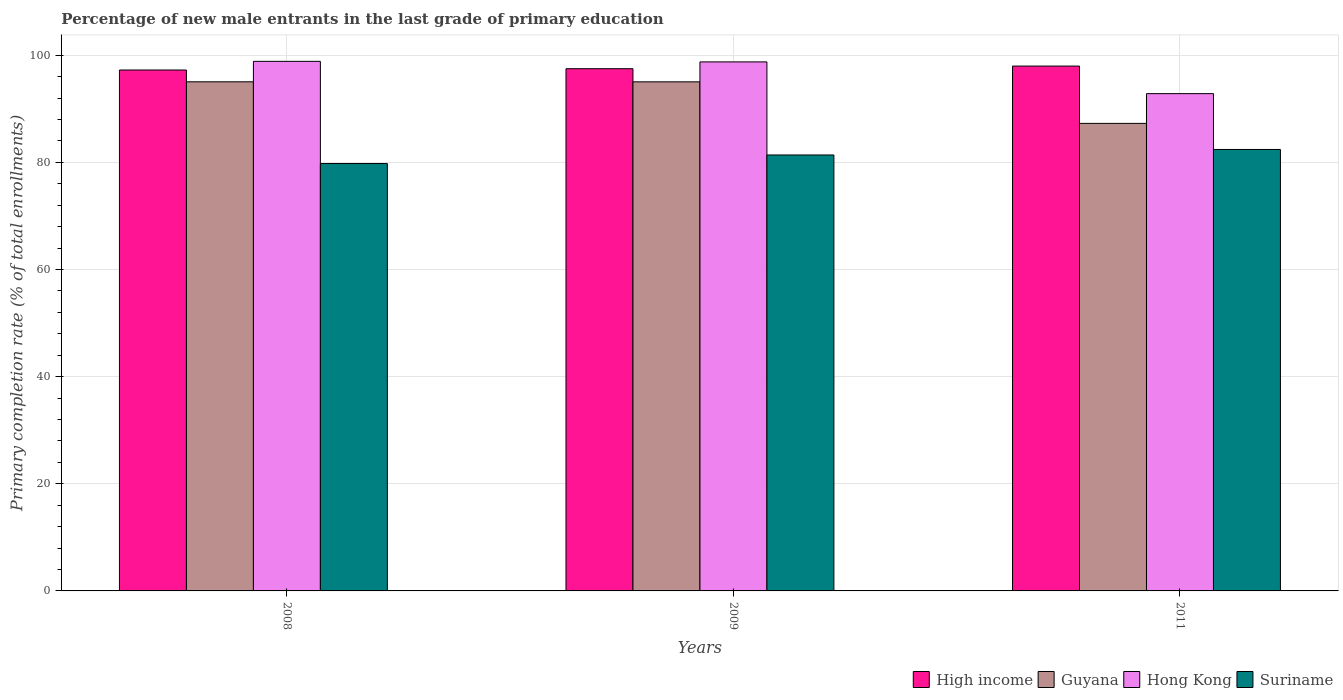Are the number of bars on each tick of the X-axis equal?
Give a very brief answer. Yes. How many bars are there on the 3rd tick from the right?
Keep it short and to the point. 4. What is the label of the 1st group of bars from the left?
Ensure brevity in your answer.  2008. In how many cases, is the number of bars for a given year not equal to the number of legend labels?
Your answer should be compact. 0. What is the percentage of new male entrants in High income in 2009?
Keep it short and to the point. 97.49. Across all years, what is the maximum percentage of new male entrants in Suriname?
Your answer should be compact. 82.41. Across all years, what is the minimum percentage of new male entrants in Hong Kong?
Your response must be concise. 92.83. In which year was the percentage of new male entrants in High income maximum?
Your answer should be very brief. 2011. In which year was the percentage of new male entrants in Hong Kong minimum?
Your response must be concise. 2011. What is the total percentage of new male entrants in Suriname in the graph?
Your answer should be compact. 243.57. What is the difference between the percentage of new male entrants in Guyana in 2009 and that in 2011?
Your answer should be compact. 7.75. What is the difference between the percentage of new male entrants in Guyana in 2008 and the percentage of new male entrants in Hong Kong in 2009?
Give a very brief answer. -3.72. What is the average percentage of new male entrants in High income per year?
Offer a terse response. 97.57. In the year 2011, what is the difference between the percentage of new male entrants in Guyana and percentage of new male entrants in Hong Kong?
Provide a short and direct response. -5.55. What is the ratio of the percentage of new male entrants in Guyana in 2008 to that in 2009?
Your answer should be very brief. 1. Is the difference between the percentage of new male entrants in Guyana in 2008 and 2009 greater than the difference between the percentage of new male entrants in Hong Kong in 2008 and 2009?
Provide a short and direct response. No. What is the difference between the highest and the second highest percentage of new male entrants in Guyana?
Offer a very short reply. 0.01. What is the difference between the highest and the lowest percentage of new male entrants in Guyana?
Offer a terse response. 7.76. In how many years, is the percentage of new male entrants in Guyana greater than the average percentage of new male entrants in Guyana taken over all years?
Keep it short and to the point. 2. Is the sum of the percentage of new male entrants in Guyana in 2009 and 2011 greater than the maximum percentage of new male entrants in High income across all years?
Your answer should be very brief. Yes. Is it the case that in every year, the sum of the percentage of new male entrants in High income and percentage of new male entrants in Guyana is greater than the sum of percentage of new male entrants in Suriname and percentage of new male entrants in Hong Kong?
Make the answer very short. No. What does the 3rd bar from the left in 2011 represents?
Offer a very short reply. Hong Kong. What does the 4th bar from the right in 2008 represents?
Provide a succinct answer. High income. Is it the case that in every year, the sum of the percentage of new male entrants in Hong Kong and percentage of new male entrants in High income is greater than the percentage of new male entrants in Guyana?
Your answer should be very brief. Yes. How many bars are there?
Keep it short and to the point. 12. What is the difference between two consecutive major ticks on the Y-axis?
Ensure brevity in your answer.  20. Does the graph contain grids?
Provide a short and direct response. Yes. How many legend labels are there?
Your answer should be compact. 4. How are the legend labels stacked?
Give a very brief answer. Horizontal. What is the title of the graph?
Offer a terse response. Percentage of new male entrants in the last grade of primary education. Does "Nicaragua" appear as one of the legend labels in the graph?
Offer a very short reply. No. What is the label or title of the Y-axis?
Offer a very short reply. Primary completion rate (% of total enrollments). What is the Primary completion rate (% of total enrollments) in High income in 2008?
Ensure brevity in your answer.  97.24. What is the Primary completion rate (% of total enrollments) in Guyana in 2008?
Make the answer very short. 95.04. What is the Primary completion rate (% of total enrollments) in Hong Kong in 2008?
Ensure brevity in your answer.  98.86. What is the Primary completion rate (% of total enrollments) of Suriname in 2008?
Ensure brevity in your answer.  79.78. What is the Primary completion rate (% of total enrollments) in High income in 2009?
Your answer should be compact. 97.49. What is the Primary completion rate (% of total enrollments) of Guyana in 2009?
Ensure brevity in your answer.  95.03. What is the Primary completion rate (% of total enrollments) in Hong Kong in 2009?
Keep it short and to the point. 98.76. What is the Primary completion rate (% of total enrollments) of Suriname in 2009?
Your response must be concise. 81.38. What is the Primary completion rate (% of total enrollments) of High income in 2011?
Offer a very short reply. 97.98. What is the Primary completion rate (% of total enrollments) in Guyana in 2011?
Your answer should be compact. 87.28. What is the Primary completion rate (% of total enrollments) in Hong Kong in 2011?
Make the answer very short. 92.83. What is the Primary completion rate (% of total enrollments) in Suriname in 2011?
Your answer should be compact. 82.41. Across all years, what is the maximum Primary completion rate (% of total enrollments) in High income?
Give a very brief answer. 97.98. Across all years, what is the maximum Primary completion rate (% of total enrollments) in Guyana?
Your response must be concise. 95.04. Across all years, what is the maximum Primary completion rate (% of total enrollments) in Hong Kong?
Make the answer very short. 98.86. Across all years, what is the maximum Primary completion rate (% of total enrollments) in Suriname?
Ensure brevity in your answer.  82.41. Across all years, what is the minimum Primary completion rate (% of total enrollments) of High income?
Provide a short and direct response. 97.24. Across all years, what is the minimum Primary completion rate (% of total enrollments) of Guyana?
Your answer should be very brief. 87.28. Across all years, what is the minimum Primary completion rate (% of total enrollments) of Hong Kong?
Your answer should be very brief. 92.83. Across all years, what is the minimum Primary completion rate (% of total enrollments) in Suriname?
Offer a very short reply. 79.78. What is the total Primary completion rate (% of total enrollments) in High income in the graph?
Keep it short and to the point. 292.7. What is the total Primary completion rate (% of total enrollments) of Guyana in the graph?
Provide a short and direct response. 277.35. What is the total Primary completion rate (% of total enrollments) of Hong Kong in the graph?
Your answer should be very brief. 290.44. What is the total Primary completion rate (% of total enrollments) of Suriname in the graph?
Offer a terse response. 243.57. What is the difference between the Primary completion rate (% of total enrollments) of High income in 2008 and that in 2009?
Give a very brief answer. -0.24. What is the difference between the Primary completion rate (% of total enrollments) of Guyana in 2008 and that in 2009?
Ensure brevity in your answer.  0.01. What is the difference between the Primary completion rate (% of total enrollments) in Hong Kong in 2008 and that in 2009?
Your answer should be very brief. 0.1. What is the difference between the Primary completion rate (% of total enrollments) in Suriname in 2008 and that in 2009?
Your response must be concise. -1.6. What is the difference between the Primary completion rate (% of total enrollments) of High income in 2008 and that in 2011?
Give a very brief answer. -0.73. What is the difference between the Primary completion rate (% of total enrollments) of Guyana in 2008 and that in 2011?
Offer a very short reply. 7.76. What is the difference between the Primary completion rate (% of total enrollments) in Hong Kong in 2008 and that in 2011?
Your response must be concise. 6.02. What is the difference between the Primary completion rate (% of total enrollments) in Suriname in 2008 and that in 2011?
Make the answer very short. -2.62. What is the difference between the Primary completion rate (% of total enrollments) of High income in 2009 and that in 2011?
Your response must be concise. -0.49. What is the difference between the Primary completion rate (% of total enrollments) in Guyana in 2009 and that in 2011?
Offer a very short reply. 7.75. What is the difference between the Primary completion rate (% of total enrollments) of Hong Kong in 2009 and that in 2011?
Make the answer very short. 5.92. What is the difference between the Primary completion rate (% of total enrollments) in Suriname in 2009 and that in 2011?
Make the answer very short. -1.03. What is the difference between the Primary completion rate (% of total enrollments) of High income in 2008 and the Primary completion rate (% of total enrollments) of Guyana in 2009?
Give a very brief answer. 2.21. What is the difference between the Primary completion rate (% of total enrollments) in High income in 2008 and the Primary completion rate (% of total enrollments) in Hong Kong in 2009?
Offer a very short reply. -1.51. What is the difference between the Primary completion rate (% of total enrollments) of High income in 2008 and the Primary completion rate (% of total enrollments) of Suriname in 2009?
Provide a succinct answer. 15.86. What is the difference between the Primary completion rate (% of total enrollments) of Guyana in 2008 and the Primary completion rate (% of total enrollments) of Hong Kong in 2009?
Your response must be concise. -3.72. What is the difference between the Primary completion rate (% of total enrollments) in Guyana in 2008 and the Primary completion rate (% of total enrollments) in Suriname in 2009?
Keep it short and to the point. 13.66. What is the difference between the Primary completion rate (% of total enrollments) in Hong Kong in 2008 and the Primary completion rate (% of total enrollments) in Suriname in 2009?
Provide a succinct answer. 17.48. What is the difference between the Primary completion rate (% of total enrollments) in High income in 2008 and the Primary completion rate (% of total enrollments) in Guyana in 2011?
Ensure brevity in your answer.  9.96. What is the difference between the Primary completion rate (% of total enrollments) in High income in 2008 and the Primary completion rate (% of total enrollments) in Hong Kong in 2011?
Your answer should be compact. 4.41. What is the difference between the Primary completion rate (% of total enrollments) of High income in 2008 and the Primary completion rate (% of total enrollments) of Suriname in 2011?
Ensure brevity in your answer.  14.83. What is the difference between the Primary completion rate (% of total enrollments) in Guyana in 2008 and the Primary completion rate (% of total enrollments) in Hong Kong in 2011?
Ensure brevity in your answer.  2.21. What is the difference between the Primary completion rate (% of total enrollments) in Guyana in 2008 and the Primary completion rate (% of total enrollments) in Suriname in 2011?
Make the answer very short. 12.63. What is the difference between the Primary completion rate (% of total enrollments) of Hong Kong in 2008 and the Primary completion rate (% of total enrollments) of Suriname in 2011?
Make the answer very short. 16.45. What is the difference between the Primary completion rate (% of total enrollments) of High income in 2009 and the Primary completion rate (% of total enrollments) of Guyana in 2011?
Your answer should be compact. 10.21. What is the difference between the Primary completion rate (% of total enrollments) in High income in 2009 and the Primary completion rate (% of total enrollments) in Hong Kong in 2011?
Your response must be concise. 4.65. What is the difference between the Primary completion rate (% of total enrollments) in High income in 2009 and the Primary completion rate (% of total enrollments) in Suriname in 2011?
Keep it short and to the point. 15.08. What is the difference between the Primary completion rate (% of total enrollments) of Guyana in 2009 and the Primary completion rate (% of total enrollments) of Hong Kong in 2011?
Provide a short and direct response. 2.2. What is the difference between the Primary completion rate (% of total enrollments) of Guyana in 2009 and the Primary completion rate (% of total enrollments) of Suriname in 2011?
Offer a very short reply. 12.62. What is the difference between the Primary completion rate (% of total enrollments) in Hong Kong in 2009 and the Primary completion rate (% of total enrollments) in Suriname in 2011?
Give a very brief answer. 16.35. What is the average Primary completion rate (% of total enrollments) of High income per year?
Offer a very short reply. 97.57. What is the average Primary completion rate (% of total enrollments) in Guyana per year?
Keep it short and to the point. 92.45. What is the average Primary completion rate (% of total enrollments) in Hong Kong per year?
Keep it short and to the point. 96.81. What is the average Primary completion rate (% of total enrollments) of Suriname per year?
Your response must be concise. 81.19. In the year 2008, what is the difference between the Primary completion rate (% of total enrollments) in High income and Primary completion rate (% of total enrollments) in Guyana?
Keep it short and to the point. 2.2. In the year 2008, what is the difference between the Primary completion rate (% of total enrollments) in High income and Primary completion rate (% of total enrollments) in Hong Kong?
Give a very brief answer. -1.62. In the year 2008, what is the difference between the Primary completion rate (% of total enrollments) of High income and Primary completion rate (% of total enrollments) of Suriname?
Offer a very short reply. 17.46. In the year 2008, what is the difference between the Primary completion rate (% of total enrollments) of Guyana and Primary completion rate (% of total enrollments) of Hong Kong?
Offer a very short reply. -3.82. In the year 2008, what is the difference between the Primary completion rate (% of total enrollments) of Guyana and Primary completion rate (% of total enrollments) of Suriname?
Your answer should be compact. 15.26. In the year 2008, what is the difference between the Primary completion rate (% of total enrollments) of Hong Kong and Primary completion rate (% of total enrollments) of Suriname?
Your response must be concise. 19.07. In the year 2009, what is the difference between the Primary completion rate (% of total enrollments) of High income and Primary completion rate (% of total enrollments) of Guyana?
Keep it short and to the point. 2.45. In the year 2009, what is the difference between the Primary completion rate (% of total enrollments) in High income and Primary completion rate (% of total enrollments) in Hong Kong?
Your response must be concise. -1.27. In the year 2009, what is the difference between the Primary completion rate (% of total enrollments) in High income and Primary completion rate (% of total enrollments) in Suriname?
Provide a short and direct response. 16.11. In the year 2009, what is the difference between the Primary completion rate (% of total enrollments) of Guyana and Primary completion rate (% of total enrollments) of Hong Kong?
Offer a very short reply. -3.72. In the year 2009, what is the difference between the Primary completion rate (% of total enrollments) in Guyana and Primary completion rate (% of total enrollments) in Suriname?
Provide a short and direct response. 13.65. In the year 2009, what is the difference between the Primary completion rate (% of total enrollments) in Hong Kong and Primary completion rate (% of total enrollments) in Suriname?
Provide a succinct answer. 17.37. In the year 2011, what is the difference between the Primary completion rate (% of total enrollments) in High income and Primary completion rate (% of total enrollments) in Guyana?
Provide a short and direct response. 10.7. In the year 2011, what is the difference between the Primary completion rate (% of total enrollments) of High income and Primary completion rate (% of total enrollments) of Hong Kong?
Your answer should be very brief. 5.14. In the year 2011, what is the difference between the Primary completion rate (% of total enrollments) in High income and Primary completion rate (% of total enrollments) in Suriname?
Ensure brevity in your answer.  15.57. In the year 2011, what is the difference between the Primary completion rate (% of total enrollments) in Guyana and Primary completion rate (% of total enrollments) in Hong Kong?
Provide a succinct answer. -5.55. In the year 2011, what is the difference between the Primary completion rate (% of total enrollments) of Guyana and Primary completion rate (% of total enrollments) of Suriname?
Make the answer very short. 4.87. In the year 2011, what is the difference between the Primary completion rate (% of total enrollments) in Hong Kong and Primary completion rate (% of total enrollments) in Suriname?
Ensure brevity in your answer.  10.42. What is the ratio of the Primary completion rate (% of total enrollments) in High income in 2008 to that in 2009?
Give a very brief answer. 1. What is the ratio of the Primary completion rate (% of total enrollments) in Guyana in 2008 to that in 2009?
Give a very brief answer. 1. What is the ratio of the Primary completion rate (% of total enrollments) of Hong Kong in 2008 to that in 2009?
Your answer should be very brief. 1. What is the ratio of the Primary completion rate (% of total enrollments) in Suriname in 2008 to that in 2009?
Make the answer very short. 0.98. What is the ratio of the Primary completion rate (% of total enrollments) of Guyana in 2008 to that in 2011?
Offer a very short reply. 1.09. What is the ratio of the Primary completion rate (% of total enrollments) in Hong Kong in 2008 to that in 2011?
Provide a short and direct response. 1.06. What is the ratio of the Primary completion rate (% of total enrollments) of Suriname in 2008 to that in 2011?
Your response must be concise. 0.97. What is the ratio of the Primary completion rate (% of total enrollments) of High income in 2009 to that in 2011?
Offer a very short reply. 0.99. What is the ratio of the Primary completion rate (% of total enrollments) of Guyana in 2009 to that in 2011?
Provide a short and direct response. 1.09. What is the ratio of the Primary completion rate (% of total enrollments) in Hong Kong in 2009 to that in 2011?
Offer a terse response. 1.06. What is the ratio of the Primary completion rate (% of total enrollments) in Suriname in 2009 to that in 2011?
Offer a terse response. 0.99. What is the difference between the highest and the second highest Primary completion rate (% of total enrollments) in High income?
Ensure brevity in your answer.  0.49. What is the difference between the highest and the second highest Primary completion rate (% of total enrollments) in Guyana?
Keep it short and to the point. 0.01. What is the difference between the highest and the second highest Primary completion rate (% of total enrollments) in Hong Kong?
Your answer should be compact. 0.1. What is the difference between the highest and the second highest Primary completion rate (% of total enrollments) of Suriname?
Make the answer very short. 1.03. What is the difference between the highest and the lowest Primary completion rate (% of total enrollments) of High income?
Provide a short and direct response. 0.73. What is the difference between the highest and the lowest Primary completion rate (% of total enrollments) in Guyana?
Your response must be concise. 7.76. What is the difference between the highest and the lowest Primary completion rate (% of total enrollments) of Hong Kong?
Provide a succinct answer. 6.02. What is the difference between the highest and the lowest Primary completion rate (% of total enrollments) in Suriname?
Provide a short and direct response. 2.62. 